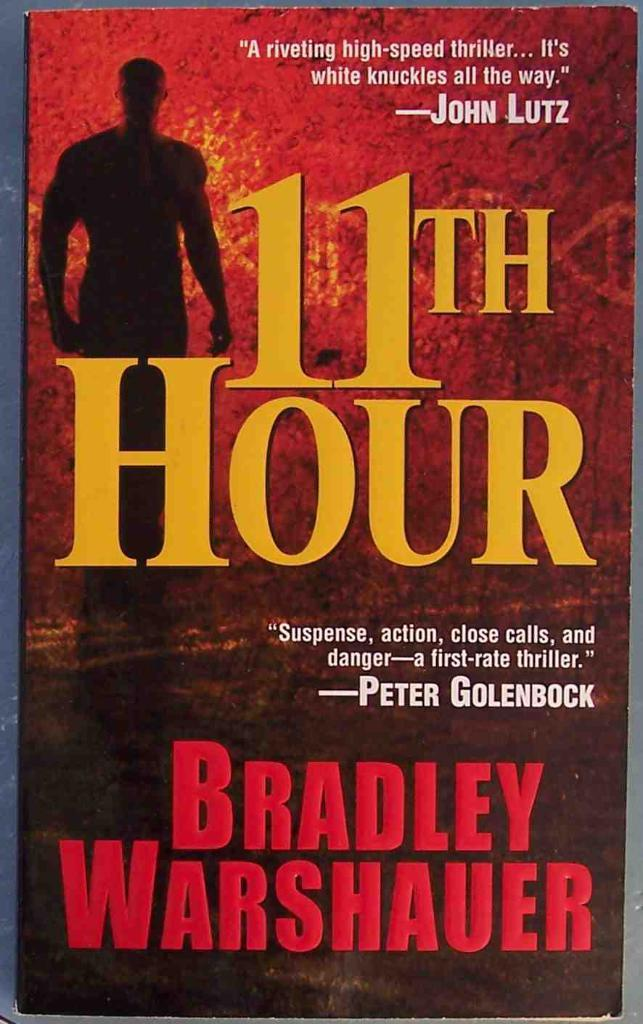<image>
Relay a brief, clear account of the picture shown. The book the 11th Hour by Bradley Warshauer is shown. 